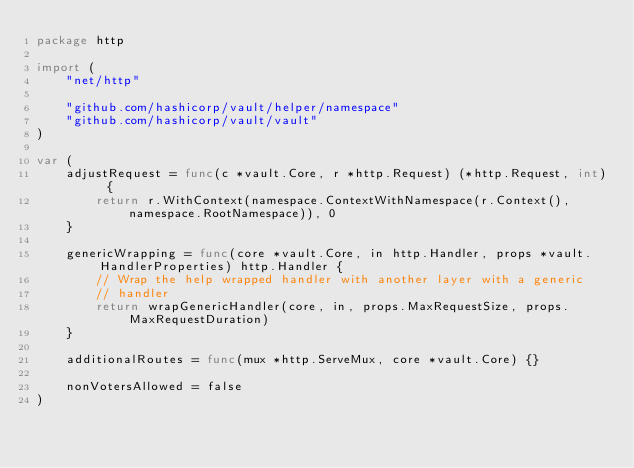<code> <loc_0><loc_0><loc_500><loc_500><_Go_>package http

import (
	"net/http"

	"github.com/hashicorp/vault/helper/namespace"
	"github.com/hashicorp/vault/vault"
)

var (
	adjustRequest = func(c *vault.Core, r *http.Request) (*http.Request, int) {
		return r.WithContext(namespace.ContextWithNamespace(r.Context(), namespace.RootNamespace)), 0
	}

	genericWrapping = func(core *vault.Core, in http.Handler, props *vault.HandlerProperties) http.Handler {
		// Wrap the help wrapped handler with another layer with a generic
		// handler
		return wrapGenericHandler(core, in, props.MaxRequestSize, props.MaxRequestDuration)
	}

	additionalRoutes = func(mux *http.ServeMux, core *vault.Core) {}

	nonVotersAllowed = false
)
</code> 